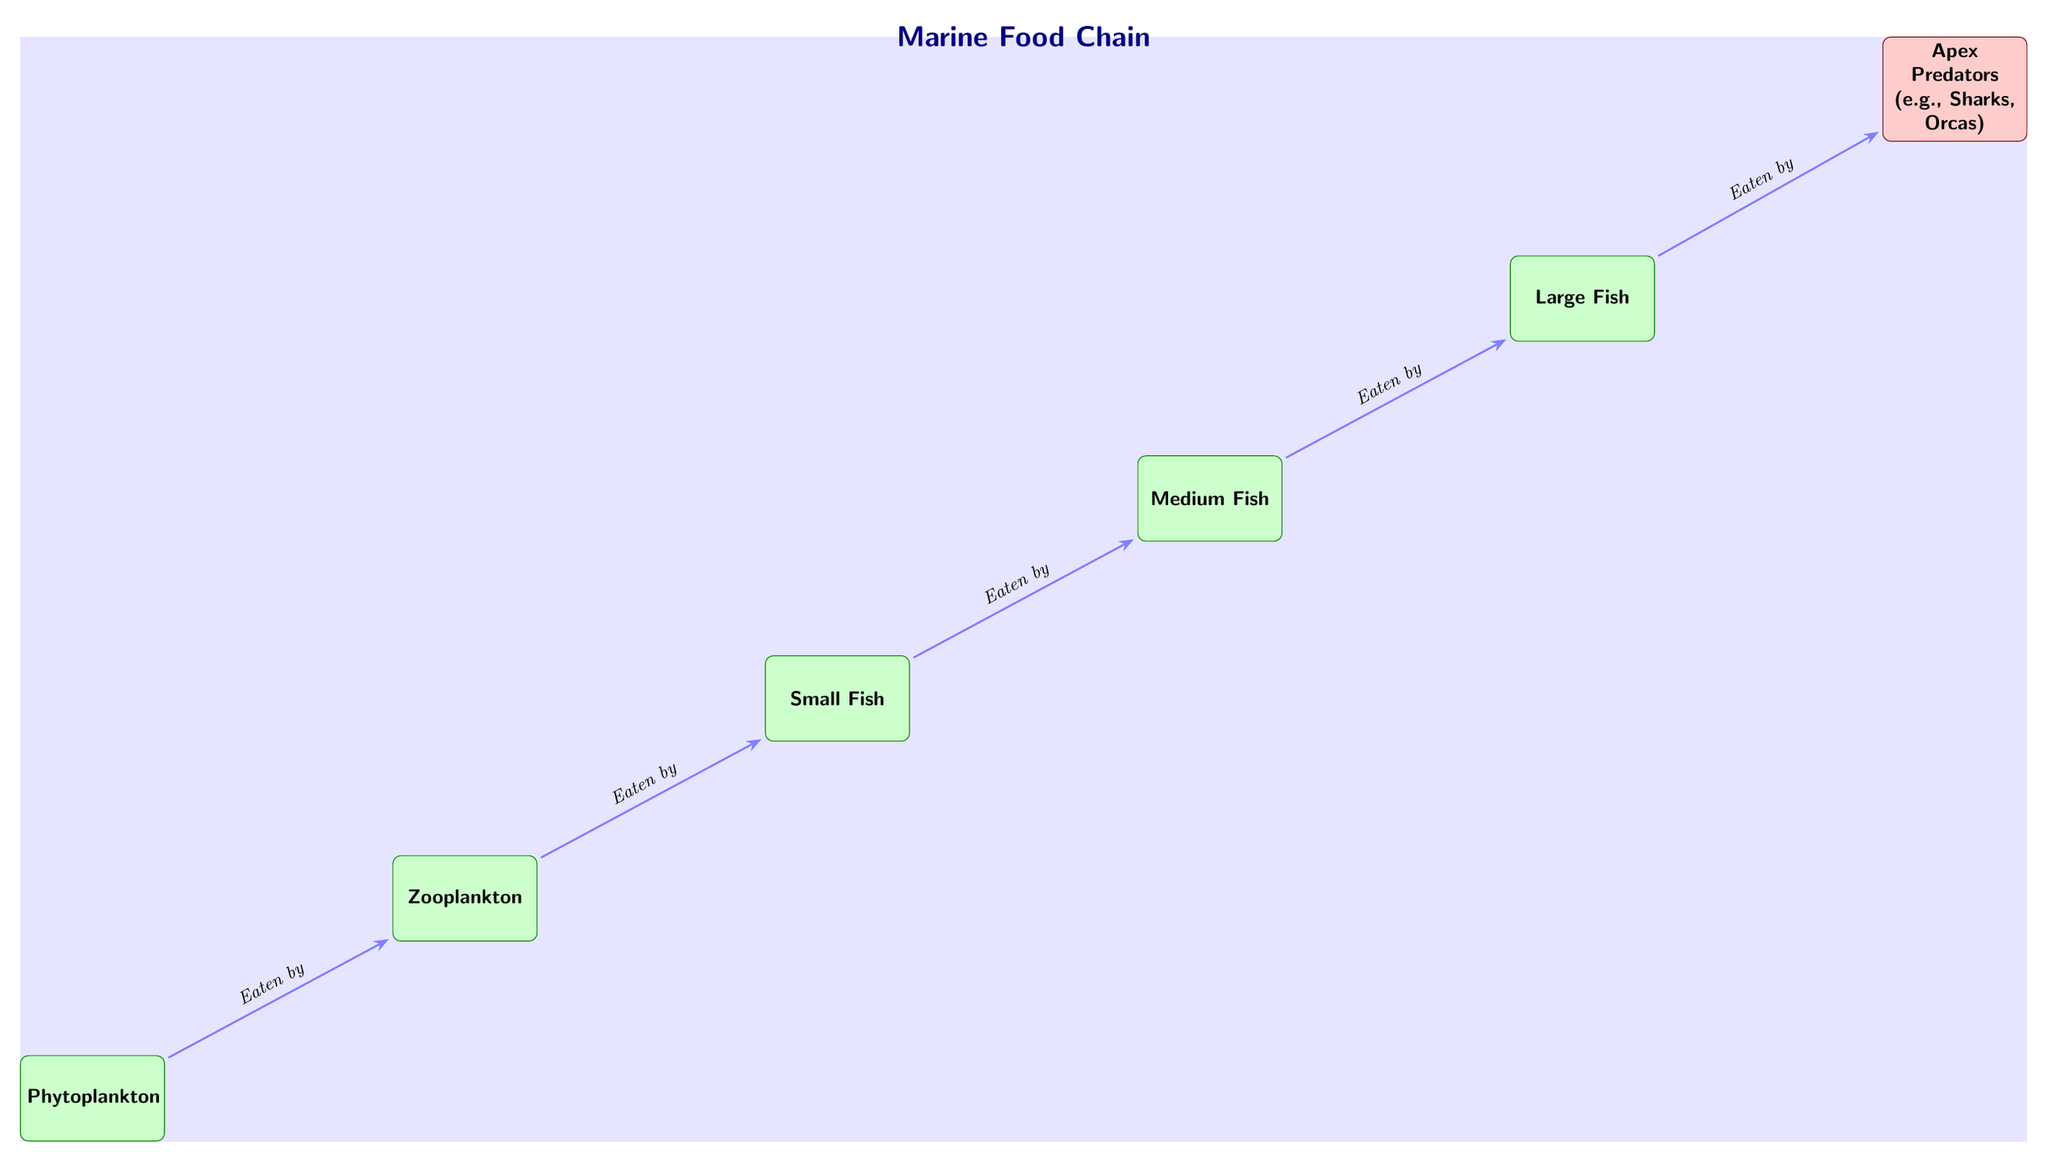How many nodes are present in the diagram? The diagram includes six nodes representing different organisms in the marine food chain. Counting each of them: Phytoplankton, Zooplankton, Small Fish, Medium Fish, Large Fish, and Apex Predators gives a total of six nodes.
Answer: 6 What is the primary producer in the food chain? The first organism in the food chain is Phytoplankton, which is responsible for producing energy through photosynthesis, making it the primary producer.
Answer: Phytoplankton Which organism is consumed by medium fish? According to the diagram, medium fish eat small fish, as indicated by the directional arrow labeled "Eaten by" pointing from small fish to medium fish.
Answer: Small Fish What type of organisms are apex predators? The apex predator node contains examples like Sharks and Orcas, categorized at the top of the food chain, which consume large fish.
Answer: Sharks, Orcas What is the relationship between zooplankton and small fish? The relationship is that small fish consume zooplankton, as represented by the arrow drawn from zooplankton to small fish along with the label "Eaten by."
Answer: Eaten by Where does the marine food chain begin? The marine food chain begins with Phytoplankton, which is the first node in the diagram and acts as the base of the food chain.
Answer: Phytoplankton Which organisms are directly consumed by apex predators? Apex predators consume large fish, as indicated by the arrow from large fish pointing towards the apex predator node, labeled "Eaten by."
Answer: Large Fish What is the direction of energy flow in the food chain? The direction of energy flow in the food chain is indicated by the arrows pointing from one organism to another, showing how energy is transferred from phytoplankton to apex predators through various stages.
Answer: Upward 